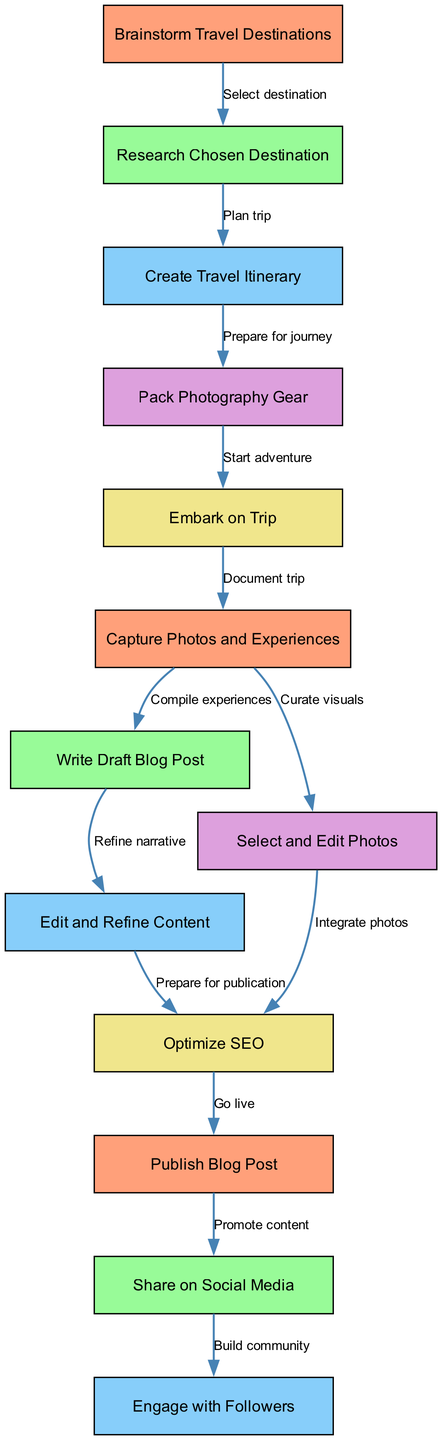What is the first step in the travel blog planning process? The diagram indicates that the first step is to "Brainstorm Travel Destinations," which initiates the flow of the process.
Answer: Brainstorm Travel Destinations How many nodes are present in the diagram? By counting all the labeled nodes listed in the diagram, we find that there are a total of 13 nodes.
Answer: 13 What is the last action taken after publishing the blog post? The diagram shows that after the blog post is published, the last action taken is to "Engage with Followers."
Answer: Engage with Followers Which node follows "Write Draft Blog Post"? According to the flowchart, the node that directly follows "Write Draft Blog Post" is "Edit and Refine Content," indicating a step in the content development process.
Answer: Edit and Refine Content What are the two actions that follow capturing photos and experiences? After "Capture Photos and Experiences," the subsequent actions are "Write Draft Blog Post" and "Select and Edit Photos," showing parallel tracks for content creation and visual curation.
Answer: Write Draft Blog Post, Select and Edit Photos What is the relationship between "Optimize SEO" and "Publish Blog Post"? The diagram shows that "Optimize SEO" is a prerequisite step that must be completed before proceeding to "Publish Blog Post," indicating it is part of the final preparations.
Answer: Prepare for publication Identify the action that prepares for the journey. The flowchart identifies the action that prepares for the journey as "Pack Photography Gear," which follows the phase of creating the travel itinerary.
Answer: Pack Photography Gear What step comes directly before "Share on Social Media"? The step that comes immediately before "Share on Social Media" is "Publish Blog Post," reflecting the sequence of posting the content before promoting it.
Answer: Publish Blog Post What two nodes are directly connected to "Create Travel Itinerary"? The diagram indicates that "Create Travel Itinerary" is connected to "Research Chosen Destination" and "Pack Photography Gear," showing its role in the planning process.
Answer: Research Chosen Destination, Pack Photography Gear 